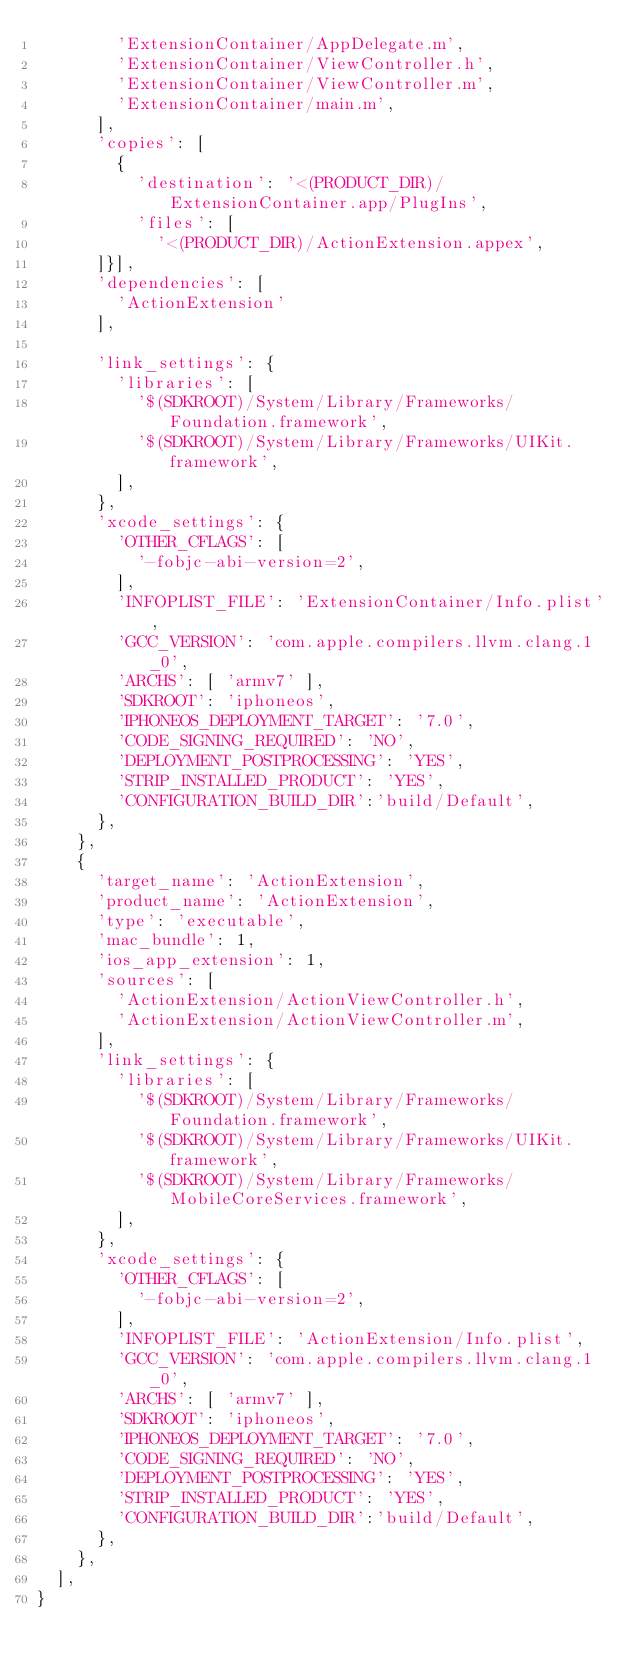<code> <loc_0><loc_0><loc_500><loc_500><_Python_>        'ExtensionContainer/AppDelegate.m',
        'ExtensionContainer/ViewController.h',
        'ExtensionContainer/ViewController.m',
        'ExtensionContainer/main.m',
      ],
      'copies': [
        {
          'destination': '<(PRODUCT_DIR)/ExtensionContainer.app/PlugIns',
          'files': [
            '<(PRODUCT_DIR)/ActionExtension.appex',
      ]}],
      'dependencies': [
        'ActionExtension'
      ],

      'link_settings': {
        'libraries': [
          '$(SDKROOT)/System/Library/Frameworks/Foundation.framework',
          '$(SDKROOT)/System/Library/Frameworks/UIKit.framework',
        ],
      },
      'xcode_settings': {
        'OTHER_CFLAGS': [
          '-fobjc-abi-version=2',
        ],
        'INFOPLIST_FILE': 'ExtensionContainer/Info.plist',
        'GCC_VERSION': 'com.apple.compilers.llvm.clang.1_0',
        'ARCHS': [ 'armv7' ],
        'SDKROOT': 'iphoneos',
        'IPHONEOS_DEPLOYMENT_TARGET': '7.0',
        'CODE_SIGNING_REQUIRED': 'NO',
        'DEPLOYMENT_POSTPROCESSING': 'YES',
        'STRIP_INSTALLED_PRODUCT': 'YES',
        'CONFIGURATION_BUILD_DIR':'build/Default',
      },
    },
    {
      'target_name': 'ActionExtension',
      'product_name': 'ActionExtension',
      'type': 'executable',
      'mac_bundle': 1,
      'ios_app_extension': 1,
      'sources': [
        'ActionExtension/ActionViewController.h',
        'ActionExtension/ActionViewController.m',
      ],
      'link_settings': {
        'libraries': [
          '$(SDKROOT)/System/Library/Frameworks/Foundation.framework',
          '$(SDKROOT)/System/Library/Frameworks/UIKit.framework',
          '$(SDKROOT)/System/Library/Frameworks/MobileCoreServices.framework',
        ],
      },
      'xcode_settings': {
        'OTHER_CFLAGS': [
          '-fobjc-abi-version=2',
        ],
        'INFOPLIST_FILE': 'ActionExtension/Info.plist',
        'GCC_VERSION': 'com.apple.compilers.llvm.clang.1_0',
        'ARCHS': [ 'armv7' ],
        'SDKROOT': 'iphoneos',
        'IPHONEOS_DEPLOYMENT_TARGET': '7.0',
        'CODE_SIGNING_REQUIRED': 'NO',
        'DEPLOYMENT_POSTPROCESSING': 'YES',
        'STRIP_INSTALLED_PRODUCT': 'YES',
        'CONFIGURATION_BUILD_DIR':'build/Default',
      },
    },
  ],
}

</code> 